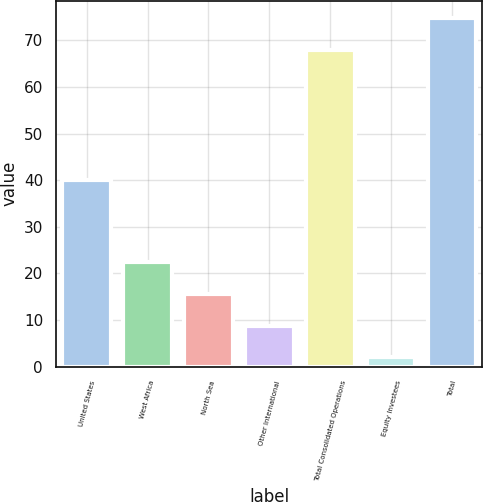<chart> <loc_0><loc_0><loc_500><loc_500><bar_chart><fcel>United States<fcel>West Africa<fcel>North Sea<fcel>Other International<fcel>Total Consolidated Operations<fcel>Equity Investees<fcel>Total<nl><fcel>40<fcel>22.4<fcel>15.6<fcel>8.8<fcel>68<fcel>2<fcel>74.8<nl></chart> 